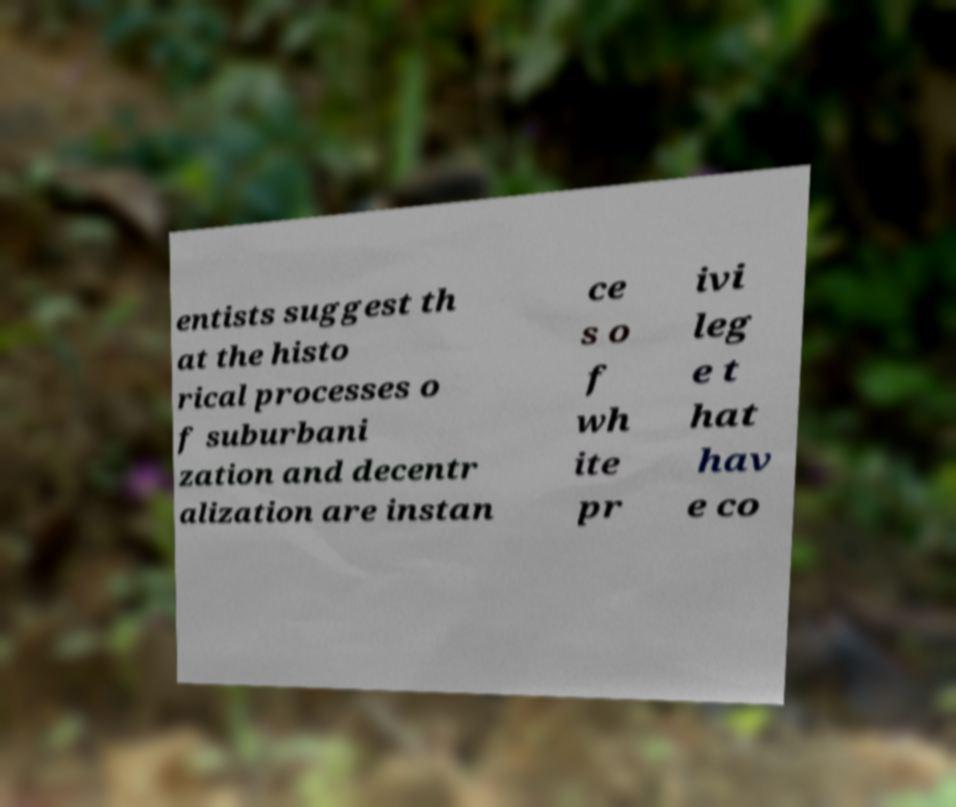What messages or text are displayed in this image? I need them in a readable, typed format. entists suggest th at the histo rical processes o f suburbani zation and decentr alization are instan ce s o f wh ite pr ivi leg e t hat hav e co 